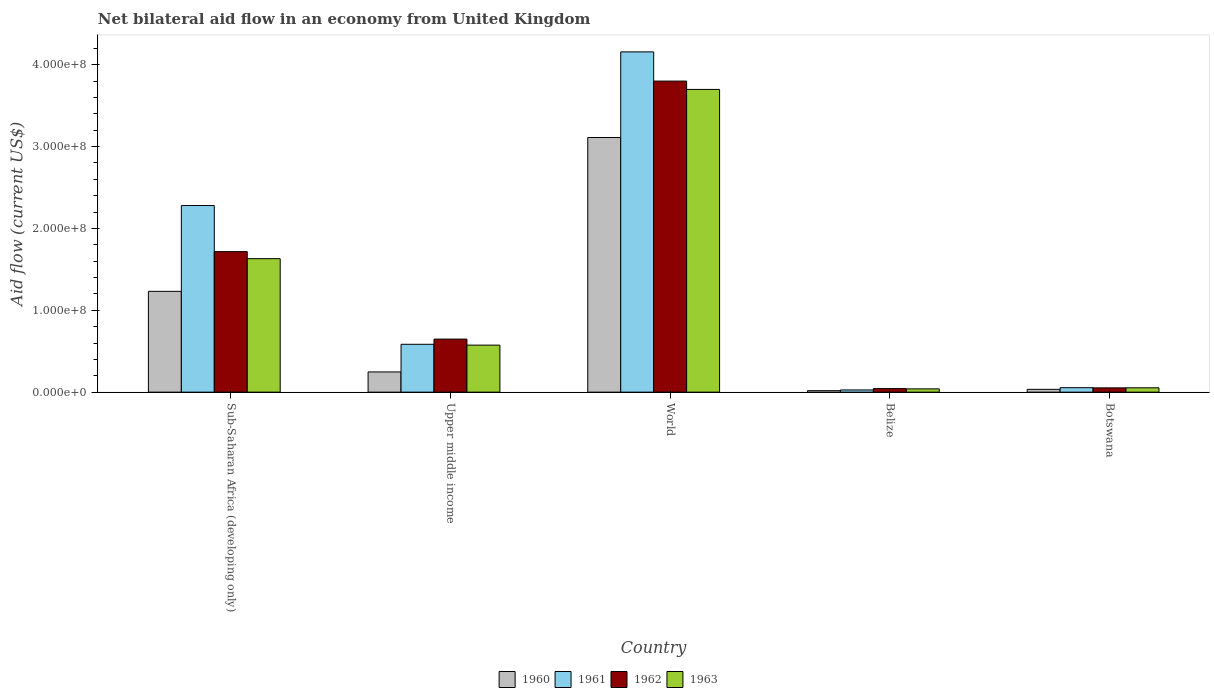How many different coloured bars are there?
Make the answer very short. 4. How many groups of bars are there?
Your response must be concise. 5. Are the number of bars per tick equal to the number of legend labels?
Provide a short and direct response. Yes. Are the number of bars on each tick of the X-axis equal?
Keep it short and to the point. Yes. How many bars are there on the 3rd tick from the left?
Provide a short and direct response. 4. How many bars are there on the 5th tick from the right?
Ensure brevity in your answer.  4. What is the label of the 2nd group of bars from the left?
Give a very brief answer. Upper middle income. In how many cases, is the number of bars for a given country not equal to the number of legend labels?
Make the answer very short. 0. What is the net bilateral aid flow in 1960 in Botswana?
Offer a very short reply. 3.43e+06. Across all countries, what is the maximum net bilateral aid flow in 1963?
Provide a succinct answer. 3.70e+08. Across all countries, what is the minimum net bilateral aid flow in 1962?
Your answer should be very brief. 4.33e+06. In which country was the net bilateral aid flow in 1962 minimum?
Keep it short and to the point. Belize. What is the total net bilateral aid flow in 1960 in the graph?
Your answer should be very brief. 4.64e+08. What is the difference between the net bilateral aid flow in 1960 in Sub-Saharan Africa (developing only) and that in Upper middle income?
Provide a short and direct response. 9.84e+07. What is the difference between the net bilateral aid flow in 1962 in Belize and the net bilateral aid flow in 1961 in World?
Provide a succinct answer. -4.11e+08. What is the average net bilateral aid flow in 1962 per country?
Provide a succinct answer. 1.25e+08. What is the difference between the net bilateral aid flow of/in 1962 and net bilateral aid flow of/in 1963 in World?
Provide a short and direct response. 1.02e+07. What is the ratio of the net bilateral aid flow in 1963 in Belize to that in World?
Provide a succinct answer. 0.01. Is the net bilateral aid flow in 1960 in Belize less than that in Upper middle income?
Ensure brevity in your answer.  Yes. Is the difference between the net bilateral aid flow in 1962 in Botswana and Sub-Saharan Africa (developing only) greater than the difference between the net bilateral aid flow in 1963 in Botswana and Sub-Saharan Africa (developing only)?
Keep it short and to the point. No. What is the difference between the highest and the second highest net bilateral aid flow in 1963?
Your response must be concise. 3.12e+08. What is the difference between the highest and the lowest net bilateral aid flow in 1962?
Your answer should be compact. 3.76e+08. Is it the case that in every country, the sum of the net bilateral aid flow in 1962 and net bilateral aid flow in 1961 is greater than the sum of net bilateral aid flow in 1963 and net bilateral aid flow in 1960?
Keep it short and to the point. No. What does the 3rd bar from the right in Upper middle income represents?
Make the answer very short. 1961. Is it the case that in every country, the sum of the net bilateral aid flow in 1963 and net bilateral aid flow in 1960 is greater than the net bilateral aid flow in 1961?
Keep it short and to the point. Yes. How many bars are there?
Keep it short and to the point. 20. How many countries are there in the graph?
Offer a terse response. 5. What is the difference between two consecutive major ticks on the Y-axis?
Make the answer very short. 1.00e+08. Are the values on the major ticks of Y-axis written in scientific E-notation?
Your response must be concise. Yes. Where does the legend appear in the graph?
Give a very brief answer. Bottom center. How many legend labels are there?
Make the answer very short. 4. How are the legend labels stacked?
Ensure brevity in your answer.  Horizontal. What is the title of the graph?
Offer a terse response. Net bilateral aid flow in an economy from United Kingdom. Does "1996" appear as one of the legend labels in the graph?
Make the answer very short. No. What is the Aid flow (current US$) of 1960 in Sub-Saharan Africa (developing only)?
Offer a terse response. 1.23e+08. What is the Aid flow (current US$) in 1961 in Sub-Saharan Africa (developing only)?
Offer a terse response. 2.28e+08. What is the Aid flow (current US$) in 1962 in Sub-Saharan Africa (developing only)?
Give a very brief answer. 1.72e+08. What is the Aid flow (current US$) in 1963 in Sub-Saharan Africa (developing only)?
Keep it short and to the point. 1.63e+08. What is the Aid flow (current US$) of 1960 in Upper middle income?
Provide a succinct answer. 2.47e+07. What is the Aid flow (current US$) in 1961 in Upper middle income?
Provide a succinct answer. 5.85e+07. What is the Aid flow (current US$) in 1962 in Upper middle income?
Ensure brevity in your answer.  6.48e+07. What is the Aid flow (current US$) in 1963 in Upper middle income?
Your response must be concise. 5.74e+07. What is the Aid flow (current US$) of 1960 in World?
Offer a very short reply. 3.11e+08. What is the Aid flow (current US$) in 1961 in World?
Keep it short and to the point. 4.16e+08. What is the Aid flow (current US$) in 1962 in World?
Your response must be concise. 3.80e+08. What is the Aid flow (current US$) in 1963 in World?
Provide a short and direct response. 3.70e+08. What is the Aid flow (current US$) of 1960 in Belize?
Offer a very short reply. 1.79e+06. What is the Aid flow (current US$) of 1961 in Belize?
Your answer should be very brief. 2.70e+06. What is the Aid flow (current US$) of 1962 in Belize?
Your answer should be very brief. 4.33e+06. What is the Aid flow (current US$) in 1963 in Belize?
Make the answer very short. 3.99e+06. What is the Aid flow (current US$) of 1960 in Botswana?
Give a very brief answer. 3.43e+06. What is the Aid flow (current US$) in 1961 in Botswana?
Offer a very short reply. 5.44e+06. What is the Aid flow (current US$) in 1962 in Botswana?
Ensure brevity in your answer.  5.22e+06. What is the Aid flow (current US$) of 1963 in Botswana?
Your answer should be very brief. 5.30e+06. Across all countries, what is the maximum Aid flow (current US$) in 1960?
Make the answer very short. 3.11e+08. Across all countries, what is the maximum Aid flow (current US$) in 1961?
Your response must be concise. 4.16e+08. Across all countries, what is the maximum Aid flow (current US$) in 1962?
Keep it short and to the point. 3.80e+08. Across all countries, what is the maximum Aid flow (current US$) in 1963?
Offer a very short reply. 3.70e+08. Across all countries, what is the minimum Aid flow (current US$) in 1960?
Offer a terse response. 1.79e+06. Across all countries, what is the minimum Aid flow (current US$) in 1961?
Your response must be concise. 2.70e+06. Across all countries, what is the minimum Aid flow (current US$) in 1962?
Your response must be concise. 4.33e+06. Across all countries, what is the minimum Aid flow (current US$) in 1963?
Give a very brief answer. 3.99e+06. What is the total Aid flow (current US$) of 1960 in the graph?
Your answer should be compact. 4.64e+08. What is the total Aid flow (current US$) of 1961 in the graph?
Offer a terse response. 7.10e+08. What is the total Aid flow (current US$) in 1962 in the graph?
Provide a succinct answer. 6.26e+08. What is the total Aid flow (current US$) in 1963 in the graph?
Give a very brief answer. 6.00e+08. What is the difference between the Aid flow (current US$) of 1960 in Sub-Saharan Africa (developing only) and that in Upper middle income?
Give a very brief answer. 9.84e+07. What is the difference between the Aid flow (current US$) of 1961 in Sub-Saharan Africa (developing only) and that in Upper middle income?
Keep it short and to the point. 1.69e+08. What is the difference between the Aid flow (current US$) of 1962 in Sub-Saharan Africa (developing only) and that in Upper middle income?
Offer a terse response. 1.07e+08. What is the difference between the Aid flow (current US$) in 1963 in Sub-Saharan Africa (developing only) and that in Upper middle income?
Ensure brevity in your answer.  1.06e+08. What is the difference between the Aid flow (current US$) in 1960 in Sub-Saharan Africa (developing only) and that in World?
Your answer should be very brief. -1.88e+08. What is the difference between the Aid flow (current US$) of 1961 in Sub-Saharan Africa (developing only) and that in World?
Your response must be concise. -1.88e+08. What is the difference between the Aid flow (current US$) of 1962 in Sub-Saharan Africa (developing only) and that in World?
Provide a short and direct response. -2.08e+08. What is the difference between the Aid flow (current US$) of 1963 in Sub-Saharan Africa (developing only) and that in World?
Your answer should be very brief. -2.07e+08. What is the difference between the Aid flow (current US$) in 1960 in Sub-Saharan Africa (developing only) and that in Belize?
Your response must be concise. 1.21e+08. What is the difference between the Aid flow (current US$) in 1961 in Sub-Saharan Africa (developing only) and that in Belize?
Make the answer very short. 2.25e+08. What is the difference between the Aid flow (current US$) of 1962 in Sub-Saharan Africa (developing only) and that in Belize?
Your answer should be compact. 1.67e+08. What is the difference between the Aid flow (current US$) in 1963 in Sub-Saharan Africa (developing only) and that in Belize?
Keep it short and to the point. 1.59e+08. What is the difference between the Aid flow (current US$) in 1960 in Sub-Saharan Africa (developing only) and that in Botswana?
Provide a succinct answer. 1.20e+08. What is the difference between the Aid flow (current US$) in 1961 in Sub-Saharan Africa (developing only) and that in Botswana?
Offer a terse response. 2.22e+08. What is the difference between the Aid flow (current US$) in 1962 in Sub-Saharan Africa (developing only) and that in Botswana?
Make the answer very short. 1.66e+08. What is the difference between the Aid flow (current US$) in 1963 in Sub-Saharan Africa (developing only) and that in Botswana?
Offer a very short reply. 1.58e+08. What is the difference between the Aid flow (current US$) of 1960 in Upper middle income and that in World?
Give a very brief answer. -2.86e+08. What is the difference between the Aid flow (current US$) of 1961 in Upper middle income and that in World?
Offer a terse response. -3.57e+08. What is the difference between the Aid flow (current US$) of 1962 in Upper middle income and that in World?
Your answer should be very brief. -3.15e+08. What is the difference between the Aid flow (current US$) in 1963 in Upper middle income and that in World?
Ensure brevity in your answer.  -3.12e+08. What is the difference between the Aid flow (current US$) in 1960 in Upper middle income and that in Belize?
Keep it short and to the point. 2.29e+07. What is the difference between the Aid flow (current US$) of 1961 in Upper middle income and that in Belize?
Your answer should be very brief. 5.58e+07. What is the difference between the Aid flow (current US$) of 1962 in Upper middle income and that in Belize?
Provide a succinct answer. 6.05e+07. What is the difference between the Aid flow (current US$) in 1963 in Upper middle income and that in Belize?
Keep it short and to the point. 5.35e+07. What is the difference between the Aid flow (current US$) in 1960 in Upper middle income and that in Botswana?
Make the answer very short. 2.13e+07. What is the difference between the Aid flow (current US$) of 1961 in Upper middle income and that in Botswana?
Provide a short and direct response. 5.30e+07. What is the difference between the Aid flow (current US$) of 1962 in Upper middle income and that in Botswana?
Give a very brief answer. 5.96e+07. What is the difference between the Aid flow (current US$) of 1963 in Upper middle income and that in Botswana?
Offer a very short reply. 5.22e+07. What is the difference between the Aid flow (current US$) of 1960 in World and that in Belize?
Provide a short and direct response. 3.09e+08. What is the difference between the Aid flow (current US$) of 1961 in World and that in Belize?
Ensure brevity in your answer.  4.13e+08. What is the difference between the Aid flow (current US$) of 1962 in World and that in Belize?
Give a very brief answer. 3.76e+08. What is the difference between the Aid flow (current US$) in 1963 in World and that in Belize?
Your response must be concise. 3.66e+08. What is the difference between the Aid flow (current US$) of 1960 in World and that in Botswana?
Provide a succinct answer. 3.08e+08. What is the difference between the Aid flow (current US$) of 1961 in World and that in Botswana?
Your answer should be compact. 4.10e+08. What is the difference between the Aid flow (current US$) of 1962 in World and that in Botswana?
Your answer should be very brief. 3.75e+08. What is the difference between the Aid flow (current US$) in 1963 in World and that in Botswana?
Provide a succinct answer. 3.65e+08. What is the difference between the Aid flow (current US$) of 1960 in Belize and that in Botswana?
Give a very brief answer. -1.64e+06. What is the difference between the Aid flow (current US$) in 1961 in Belize and that in Botswana?
Keep it short and to the point. -2.74e+06. What is the difference between the Aid flow (current US$) of 1962 in Belize and that in Botswana?
Give a very brief answer. -8.90e+05. What is the difference between the Aid flow (current US$) in 1963 in Belize and that in Botswana?
Offer a very short reply. -1.31e+06. What is the difference between the Aid flow (current US$) in 1960 in Sub-Saharan Africa (developing only) and the Aid flow (current US$) in 1961 in Upper middle income?
Your response must be concise. 6.47e+07. What is the difference between the Aid flow (current US$) of 1960 in Sub-Saharan Africa (developing only) and the Aid flow (current US$) of 1962 in Upper middle income?
Provide a short and direct response. 5.83e+07. What is the difference between the Aid flow (current US$) of 1960 in Sub-Saharan Africa (developing only) and the Aid flow (current US$) of 1963 in Upper middle income?
Make the answer very short. 6.57e+07. What is the difference between the Aid flow (current US$) in 1961 in Sub-Saharan Africa (developing only) and the Aid flow (current US$) in 1962 in Upper middle income?
Offer a very short reply. 1.63e+08. What is the difference between the Aid flow (current US$) of 1961 in Sub-Saharan Africa (developing only) and the Aid flow (current US$) of 1963 in Upper middle income?
Provide a short and direct response. 1.70e+08. What is the difference between the Aid flow (current US$) of 1962 in Sub-Saharan Africa (developing only) and the Aid flow (current US$) of 1963 in Upper middle income?
Make the answer very short. 1.14e+08. What is the difference between the Aid flow (current US$) of 1960 in Sub-Saharan Africa (developing only) and the Aid flow (current US$) of 1961 in World?
Provide a short and direct response. -2.93e+08. What is the difference between the Aid flow (current US$) in 1960 in Sub-Saharan Africa (developing only) and the Aid flow (current US$) in 1962 in World?
Provide a succinct answer. -2.57e+08. What is the difference between the Aid flow (current US$) of 1960 in Sub-Saharan Africa (developing only) and the Aid flow (current US$) of 1963 in World?
Offer a terse response. -2.47e+08. What is the difference between the Aid flow (current US$) of 1961 in Sub-Saharan Africa (developing only) and the Aid flow (current US$) of 1962 in World?
Offer a terse response. -1.52e+08. What is the difference between the Aid flow (current US$) of 1961 in Sub-Saharan Africa (developing only) and the Aid flow (current US$) of 1963 in World?
Your answer should be compact. -1.42e+08. What is the difference between the Aid flow (current US$) of 1962 in Sub-Saharan Africa (developing only) and the Aid flow (current US$) of 1963 in World?
Your answer should be compact. -1.98e+08. What is the difference between the Aid flow (current US$) in 1960 in Sub-Saharan Africa (developing only) and the Aid flow (current US$) in 1961 in Belize?
Give a very brief answer. 1.20e+08. What is the difference between the Aid flow (current US$) of 1960 in Sub-Saharan Africa (developing only) and the Aid flow (current US$) of 1962 in Belize?
Give a very brief answer. 1.19e+08. What is the difference between the Aid flow (current US$) in 1960 in Sub-Saharan Africa (developing only) and the Aid flow (current US$) in 1963 in Belize?
Your response must be concise. 1.19e+08. What is the difference between the Aid flow (current US$) of 1961 in Sub-Saharan Africa (developing only) and the Aid flow (current US$) of 1962 in Belize?
Your answer should be very brief. 2.24e+08. What is the difference between the Aid flow (current US$) in 1961 in Sub-Saharan Africa (developing only) and the Aid flow (current US$) in 1963 in Belize?
Your answer should be very brief. 2.24e+08. What is the difference between the Aid flow (current US$) of 1962 in Sub-Saharan Africa (developing only) and the Aid flow (current US$) of 1963 in Belize?
Offer a very short reply. 1.68e+08. What is the difference between the Aid flow (current US$) in 1960 in Sub-Saharan Africa (developing only) and the Aid flow (current US$) in 1961 in Botswana?
Provide a short and direct response. 1.18e+08. What is the difference between the Aid flow (current US$) in 1960 in Sub-Saharan Africa (developing only) and the Aid flow (current US$) in 1962 in Botswana?
Offer a terse response. 1.18e+08. What is the difference between the Aid flow (current US$) of 1960 in Sub-Saharan Africa (developing only) and the Aid flow (current US$) of 1963 in Botswana?
Your answer should be very brief. 1.18e+08. What is the difference between the Aid flow (current US$) in 1961 in Sub-Saharan Africa (developing only) and the Aid flow (current US$) in 1962 in Botswana?
Make the answer very short. 2.23e+08. What is the difference between the Aid flow (current US$) in 1961 in Sub-Saharan Africa (developing only) and the Aid flow (current US$) in 1963 in Botswana?
Your answer should be very brief. 2.23e+08. What is the difference between the Aid flow (current US$) of 1962 in Sub-Saharan Africa (developing only) and the Aid flow (current US$) of 1963 in Botswana?
Offer a very short reply. 1.66e+08. What is the difference between the Aid flow (current US$) in 1960 in Upper middle income and the Aid flow (current US$) in 1961 in World?
Make the answer very short. -3.91e+08. What is the difference between the Aid flow (current US$) of 1960 in Upper middle income and the Aid flow (current US$) of 1962 in World?
Provide a short and direct response. -3.55e+08. What is the difference between the Aid flow (current US$) in 1960 in Upper middle income and the Aid flow (current US$) in 1963 in World?
Ensure brevity in your answer.  -3.45e+08. What is the difference between the Aid flow (current US$) in 1961 in Upper middle income and the Aid flow (current US$) in 1962 in World?
Your answer should be compact. -3.22e+08. What is the difference between the Aid flow (current US$) in 1961 in Upper middle income and the Aid flow (current US$) in 1963 in World?
Your response must be concise. -3.11e+08. What is the difference between the Aid flow (current US$) of 1962 in Upper middle income and the Aid flow (current US$) of 1963 in World?
Make the answer very short. -3.05e+08. What is the difference between the Aid flow (current US$) of 1960 in Upper middle income and the Aid flow (current US$) of 1961 in Belize?
Your response must be concise. 2.20e+07. What is the difference between the Aid flow (current US$) of 1960 in Upper middle income and the Aid flow (current US$) of 1962 in Belize?
Provide a succinct answer. 2.04e+07. What is the difference between the Aid flow (current US$) in 1960 in Upper middle income and the Aid flow (current US$) in 1963 in Belize?
Offer a terse response. 2.07e+07. What is the difference between the Aid flow (current US$) of 1961 in Upper middle income and the Aid flow (current US$) of 1962 in Belize?
Offer a very short reply. 5.41e+07. What is the difference between the Aid flow (current US$) of 1961 in Upper middle income and the Aid flow (current US$) of 1963 in Belize?
Offer a terse response. 5.45e+07. What is the difference between the Aid flow (current US$) in 1962 in Upper middle income and the Aid flow (current US$) in 1963 in Belize?
Your response must be concise. 6.08e+07. What is the difference between the Aid flow (current US$) in 1960 in Upper middle income and the Aid flow (current US$) in 1961 in Botswana?
Offer a very short reply. 1.93e+07. What is the difference between the Aid flow (current US$) of 1960 in Upper middle income and the Aid flow (current US$) of 1962 in Botswana?
Your answer should be very brief. 1.95e+07. What is the difference between the Aid flow (current US$) of 1960 in Upper middle income and the Aid flow (current US$) of 1963 in Botswana?
Your response must be concise. 1.94e+07. What is the difference between the Aid flow (current US$) of 1961 in Upper middle income and the Aid flow (current US$) of 1962 in Botswana?
Give a very brief answer. 5.32e+07. What is the difference between the Aid flow (current US$) in 1961 in Upper middle income and the Aid flow (current US$) in 1963 in Botswana?
Give a very brief answer. 5.32e+07. What is the difference between the Aid flow (current US$) of 1962 in Upper middle income and the Aid flow (current US$) of 1963 in Botswana?
Provide a succinct answer. 5.95e+07. What is the difference between the Aid flow (current US$) of 1960 in World and the Aid flow (current US$) of 1961 in Belize?
Offer a terse response. 3.08e+08. What is the difference between the Aid flow (current US$) of 1960 in World and the Aid flow (current US$) of 1962 in Belize?
Offer a very short reply. 3.07e+08. What is the difference between the Aid flow (current US$) in 1960 in World and the Aid flow (current US$) in 1963 in Belize?
Your answer should be compact. 3.07e+08. What is the difference between the Aid flow (current US$) in 1961 in World and the Aid flow (current US$) in 1962 in Belize?
Provide a short and direct response. 4.11e+08. What is the difference between the Aid flow (current US$) of 1961 in World and the Aid flow (current US$) of 1963 in Belize?
Provide a succinct answer. 4.12e+08. What is the difference between the Aid flow (current US$) in 1962 in World and the Aid flow (current US$) in 1963 in Belize?
Offer a very short reply. 3.76e+08. What is the difference between the Aid flow (current US$) in 1960 in World and the Aid flow (current US$) in 1961 in Botswana?
Make the answer very short. 3.06e+08. What is the difference between the Aid flow (current US$) of 1960 in World and the Aid flow (current US$) of 1962 in Botswana?
Keep it short and to the point. 3.06e+08. What is the difference between the Aid flow (current US$) of 1960 in World and the Aid flow (current US$) of 1963 in Botswana?
Your answer should be very brief. 3.06e+08. What is the difference between the Aid flow (current US$) in 1961 in World and the Aid flow (current US$) in 1962 in Botswana?
Provide a succinct answer. 4.10e+08. What is the difference between the Aid flow (current US$) of 1961 in World and the Aid flow (current US$) of 1963 in Botswana?
Your answer should be compact. 4.10e+08. What is the difference between the Aid flow (current US$) in 1962 in World and the Aid flow (current US$) in 1963 in Botswana?
Offer a very short reply. 3.75e+08. What is the difference between the Aid flow (current US$) in 1960 in Belize and the Aid flow (current US$) in 1961 in Botswana?
Keep it short and to the point. -3.65e+06. What is the difference between the Aid flow (current US$) of 1960 in Belize and the Aid flow (current US$) of 1962 in Botswana?
Provide a short and direct response. -3.43e+06. What is the difference between the Aid flow (current US$) in 1960 in Belize and the Aid flow (current US$) in 1963 in Botswana?
Your answer should be compact. -3.51e+06. What is the difference between the Aid flow (current US$) in 1961 in Belize and the Aid flow (current US$) in 1962 in Botswana?
Offer a very short reply. -2.52e+06. What is the difference between the Aid flow (current US$) in 1961 in Belize and the Aid flow (current US$) in 1963 in Botswana?
Make the answer very short. -2.60e+06. What is the difference between the Aid flow (current US$) of 1962 in Belize and the Aid flow (current US$) of 1963 in Botswana?
Give a very brief answer. -9.70e+05. What is the average Aid flow (current US$) of 1960 per country?
Offer a very short reply. 9.28e+07. What is the average Aid flow (current US$) in 1961 per country?
Offer a terse response. 1.42e+08. What is the average Aid flow (current US$) in 1962 per country?
Your answer should be compact. 1.25e+08. What is the average Aid flow (current US$) in 1963 per country?
Your answer should be compact. 1.20e+08. What is the difference between the Aid flow (current US$) in 1960 and Aid flow (current US$) in 1961 in Sub-Saharan Africa (developing only)?
Make the answer very short. -1.05e+08. What is the difference between the Aid flow (current US$) of 1960 and Aid flow (current US$) of 1962 in Sub-Saharan Africa (developing only)?
Give a very brief answer. -4.85e+07. What is the difference between the Aid flow (current US$) of 1960 and Aid flow (current US$) of 1963 in Sub-Saharan Africa (developing only)?
Your answer should be compact. -3.99e+07. What is the difference between the Aid flow (current US$) of 1961 and Aid flow (current US$) of 1962 in Sub-Saharan Africa (developing only)?
Provide a short and direct response. 5.63e+07. What is the difference between the Aid flow (current US$) of 1961 and Aid flow (current US$) of 1963 in Sub-Saharan Africa (developing only)?
Your answer should be very brief. 6.49e+07. What is the difference between the Aid flow (current US$) of 1962 and Aid flow (current US$) of 1963 in Sub-Saharan Africa (developing only)?
Provide a short and direct response. 8.61e+06. What is the difference between the Aid flow (current US$) of 1960 and Aid flow (current US$) of 1961 in Upper middle income?
Your answer should be compact. -3.38e+07. What is the difference between the Aid flow (current US$) in 1960 and Aid flow (current US$) in 1962 in Upper middle income?
Your answer should be compact. -4.01e+07. What is the difference between the Aid flow (current US$) of 1960 and Aid flow (current US$) of 1963 in Upper middle income?
Your answer should be very brief. -3.28e+07. What is the difference between the Aid flow (current US$) in 1961 and Aid flow (current US$) in 1962 in Upper middle income?
Offer a terse response. -6.33e+06. What is the difference between the Aid flow (current US$) of 1961 and Aid flow (current US$) of 1963 in Upper middle income?
Your answer should be very brief. 1.02e+06. What is the difference between the Aid flow (current US$) of 1962 and Aid flow (current US$) of 1963 in Upper middle income?
Make the answer very short. 7.35e+06. What is the difference between the Aid flow (current US$) in 1960 and Aid flow (current US$) in 1961 in World?
Provide a succinct answer. -1.05e+08. What is the difference between the Aid flow (current US$) of 1960 and Aid flow (current US$) of 1962 in World?
Give a very brief answer. -6.89e+07. What is the difference between the Aid flow (current US$) of 1960 and Aid flow (current US$) of 1963 in World?
Offer a terse response. -5.88e+07. What is the difference between the Aid flow (current US$) of 1961 and Aid flow (current US$) of 1962 in World?
Ensure brevity in your answer.  3.57e+07. What is the difference between the Aid flow (current US$) of 1961 and Aid flow (current US$) of 1963 in World?
Offer a very short reply. 4.58e+07. What is the difference between the Aid flow (current US$) in 1962 and Aid flow (current US$) in 1963 in World?
Provide a succinct answer. 1.02e+07. What is the difference between the Aid flow (current US$) in 1960 and Aid flow (current US$) in 1961 in Belize?
Your response must be concise. -9.10e+05. What is the difference between the Aid flow (current US$) in 1960 and Aid flow (current US$) in 1962 in Belize?
Provide a short and direct response. -2.54e+06. What is the difference between the Aid flow (current US$) in 1960 and Aid flow (current US$) in 1963 in Belize?
Your answer should be very brief. -2.20e+06. What is the difference between the Aid flow (current US$) of 1961 and Aid flow (current US$) of 1962 in Belize?
Your answer should be very brief. -1.63e+06. What is the difference between the Aid flow (current US$) in 1961 and Aid flow (current US$) in 1963 in Belize?
Your answer should be very brief. -1.29e+06. What is the difference between the Aid flow (current US$) of 1960 and Aid flow (current US$) of 1961 in Botswana?
Offer a terse response. -2.01e+06. What is the difference between the Aid flow (current US$) of 1960 and Aid flow (current US$) of 1962 in Botswana?
Ensure brevity in your answer.  -1.79e+06. What is the difference between the Aid flow (current US$) in 1960 and Aid flow (current US$) in 1963 in Botswana?
Your answer should be very brief. -1.87e+06. What is the ratio of the Aid flow (current US$) in 1960 in Sub-Saharan Africa (developing only) to that in Upper middle income?
Your answer should be very brief. 4.99. What is the ratio of the Aid flow (current US$) of 1961 in Sub-Saharan Africa (developing only) to that in Upper middle income?
Make the answer very short. 3.9. What is the ratio of the Aid flow (current US$) of 1962 in Sub-Saharan Africa (developing only) to that in Upper middle income?
Ensure brevity in your answer.  2.65. What is the ratio of the Aid flow (current US$) of 1963 in Sub-Saharan Africa (developing only) to that in Upper middle income?
Provide a succinct answer. 2.84. What is the ratio of the Aid flow (current US$) of 1960 in Sub-Saharan Africa (developing only) to that in World?
Provide a short and direct response. 0.4. What is the ratio of the Aid flow (current US$) of 1961 in Sub-Saharan Africa (developing only) to that in World?
Your response must be concise. 0.55. What is the ratio of the Aid flow (current US$) of 1962 in Sub-Saharan Africa (developing only) to that in World?
Offer a very short reply. 0.45. What is the ratio of the Aid flow (current US$) of 1963 in Sub-Saharan Africa (developing only) to that in World?
Provide a succinct answer. 0.44. What is the ratio of the Aid flow (current US$) of 1960 in Sub-Saharan Africa (developing only) to that in Belize?
Your answer should be compact. 68.79. What is the ratio of the Aid flow (current US$) in 1961 in Sub-Saharan Africa (developing only) to that in Belize?
Keep it short and to the point. 84.42. What is the ratio of the Aid flow (current US$) of 1962 in Sub-Saharan Africa (developing only) to that in Belize?
Keep it short and to the point. 39.65. What is the ratio of the Aid flow (current US$) in 1963 in Sub-Saharan Africa (developing only) to that in Belize?
Offer a terse response. 40.87. What is the ratio of the Aid flow (current US$) in 1960 in Sub-Saharan Africa (developing only) to that in Botswana?
Ensure brevity in your answer.  35.9. What is the ratio of the Aid flow (current US$) of 1961 in Sub-Saharan Africa (developing only) to that in Botswana?
Offer a terse response. 41.9. What is the ratio of the Aid flow (current US$) of 1962 in Sub-Saharan Africa (developing only) to that in Botswana?
Make the answer very short. 32.89. What is the ratio of the Aid flow (current US$) in 1963 in Sub-Saharan Africa (developing only) to that in Botswana?
Your answer should be compact. 30.77. What is the ratio of the Aid flow (current US$) of 1960 in Upper middle income to that in World?
Your answer should be very brief. 0.08. What is the ratio of the Aid flow (current US$) of 1961 in Upper middle income to that in World?
Provide a short and direct response. 0.14. What is the ratio of the Aid flow (current US$) in 1962 in Upper middle income to that in World?
Your response must be concise. 0.17. What is the ratio of the Aid flow (current US$) of 1963 in Upper middle income to that in World?
Give a very brief answer. 0.16. What is the ratio of the Aid flow (current US$) of 1960 in Upper middle income to that in Belize?
Keep it short and to the point. 13.8. What is the ratio of the Aid flow (current US$) in 1961 in Upper middle income to that in Belize?
Make the answer very short. 21.66. What is the ratio of the Aid flow (current US$) of 1962 in Upper middle income to that in Belize?
Make the answer very short. 14.97. What is the ratio of the Aid flow (current US$) in 1963 in Upper middle income to that in Belize?
Make the answer very short. 14.4. What is the ratio of the Aid flow (current US$) in 1960 in Upper middle income to that in Botswana?
Make the answer very short. 7.2. What is the ratio of the Aid flow (current US$) of 1961 in Upper middle income to that in Botswana?
Provide a short and direct response. 10.75. What is the ratio of the Aid flow (current US$) in 1962 in Upper middle income to that in Botswana?
Your response must be concise. 12.41. What is the ratio of the Aid flow (current US$) of 1963 in Upper middle income to that in Botswana?
Your response must be concise. 10.84. What is the ratio of the Aid flow (current US$) of 1960 in World to that in Belize?
Provide a short and direct response. 173.77. What is the ratio of the Aid flow (current US$) in 1961 in World to that in Belize?
Offer a terse response. 153.94. What is the ratio of the Aid flow (current US$) in 1962 in World to that in Belize?
Your answer should be compact. 87.75. What is the ratio of the Aid flow (current US$) in 1963 in World to that in Belize?
Give a very brief answer. 92.68. What is the ratio of the Aid flow (current US$) in 1960 in World to that in Botswana?
Your answer should be compact. 90.69. What is the ratio of the Aid flow (current US$) of 1961 in World to that in Botswana?
Your answer should be compact. 76.4. What is the ratio of the Aid flow (current US$) of 1962 in World to that in Botswana?
Offer a terse response. 72.79. What is the ratio of the Aid flow (current US$) of 1963 in World to that in Botswana?
Your answer should be very brief. 69.78. What is the ratio of the Aid flow (current US$) in 1960 in Belize to that in Botswana?
Offer a terse response. 0.52. What is the ratio of the Aid flow (current US$) of 1961 in Belize to that in Botswana?
Offer a very short reply. 0.5. What is the ratio of the Aid flow (current US$) of 1962 in Belize to that in Botswana?
Your answer should be very brief. 0.83. What is the ratio of the Aid flow (current US$) of 1963 in Belize to that in Botswana?
Offer a terse response. 0.75. What is the difference between the highest and the second highest Aid flow (current US$) in 1960?
Keep it short and to the point. 1.88e+08. What is the difference between the highest and the second highest Aid flow (current US$) of 1961?
Offer a terse response. 1.88e+08. What is the difference between the highest and the second highest Aid flow (current US$) in 1962?
Give a very brief answer. 2.08e+08. What is the difference between the highest and the second highest Aid flow (current US$) of 1963?
Offer a terse response. 2.07e+08. What is the difference between the highest and the lowest Aid flow (current US$) in 1960?
Your answer should be compact. 3.09e+08. What is the difference between the highest and the lowest Aid flow (current US$) of 1961?
Your response must be concise. 4.13e+08. What is the difference between the highest and the lowest Aid flow (current US$) of 1962?
Your answer should be very brief. 3.76e+08. What is the difference between the highest and the lowest Aid flow (current US$) of 1963?
Give a very brief answer. 3.66e+08. 